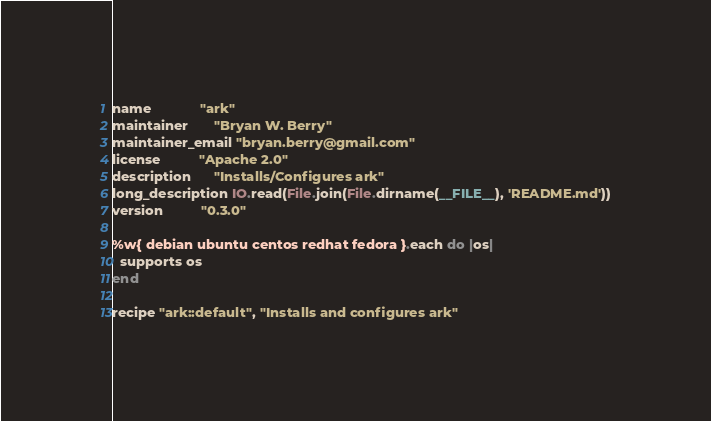Convert code to text. <code><loc_0><loc_0><loc_500><loc_500><_Ruby_>name             "ark"
maintainer       "Bryan W. Berry"
maintainer_email "bryan.berry@gmail.com"
license          "Apache 2.0"
description      "Installs/Configures ark"
long_description IO.read(File.join(File.dirname(__FILE__), 'README.md'))
version          "0.3.0"

%w{ debian ubuntu centos redhat fedora }.each do |os|
  supports os
end

recipe "ark::default", "Installs and configures ark"
</code> 